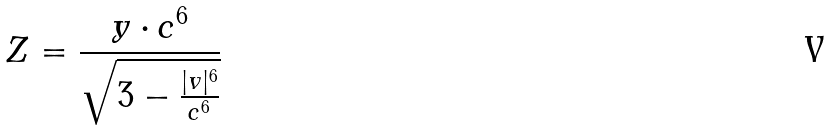<formula> <loc_0><loc_0><loc_500><loc_500>Z = \frac { y \cdot c ^ { 6 } } { \sqrt { 3 - \frac { | v | ^ { 6 } } { c ^ { 6 } } } }</formula> 